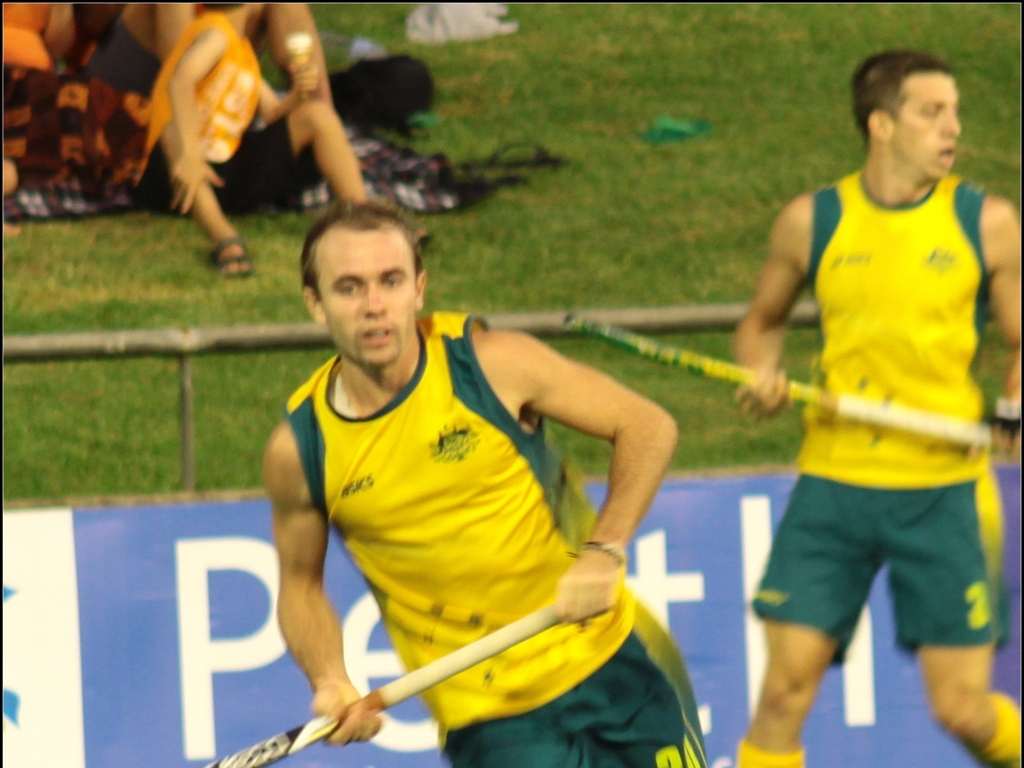Describe the atmosphere of the venue where this event is taking place. The atmosphere of the venue seems to be vibrant and energetic, which is suggested by the vivid colors and blurred motion of the crowd in the background. Even though the focus on the audience is not sharp, their presence implies a lively ambiance characteristic of a sports event, with fans possibly cheering or reacting to the ongoing game. 